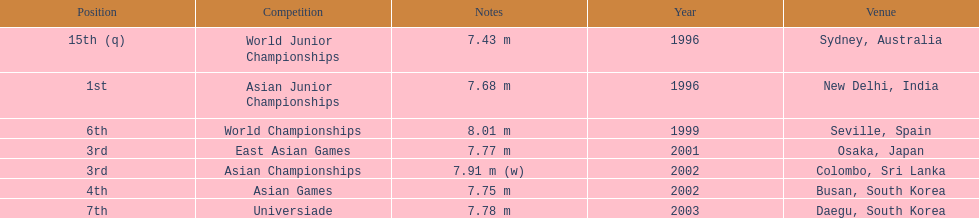Which competition did this person compete in immediately before the east asian games in 2001? World Championships. 